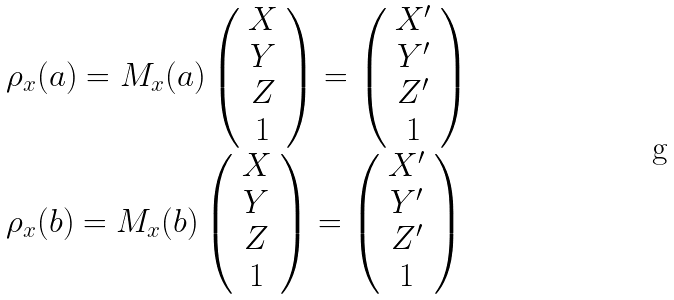<formula> <loc_0><loc_0><loc_500><loc_500>\begin{array} { l } \rho _ { x } ( a ) = M _ { x } ( a ) \left ( \begin{array} { c } X \\ Y \\ Z \\ 1 \end{array} \right ) = \left ( \begin{array} { c } X ^ { \prime } \\ Y ^ { \prime } \\ Z ^ { \prime } \\ 1 \end{array} \right ) \\ \rho _ { x } ( b ) = M _ { x } ( b ) \left ( \begin{array} { c } X \\ Y \\ Z \\ 1 \end{array} \right ) = \left ( \begin{array} { c } X ^ { \prime } \\ Y ^ { \prime } \\ Z ^ { \prime } \\ 1 \end{array} \right ) \end{array}</formula> 